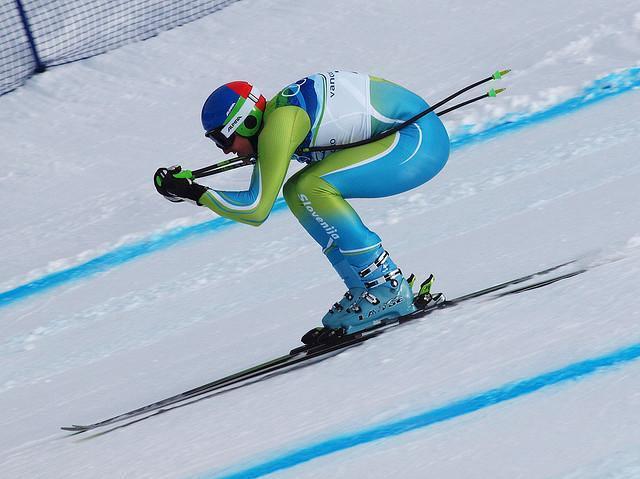How many ski are in the picture?
Give a very brief answer. 2. How many bananas are in the picture?
Give a very brief answer. 0. 